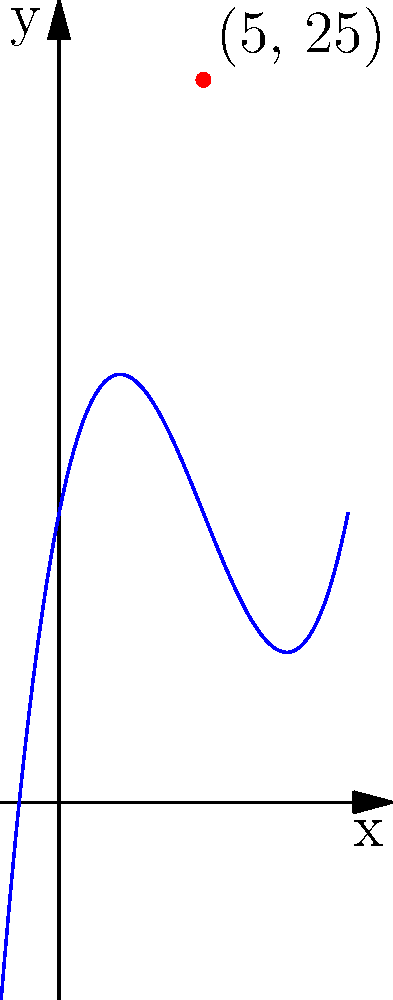As the visual designer for a futuristic sci-fi film, you're tasked with creating a curved set piece for an alien spaceship. The director wants the curve to follow a cubic polynomial function. You've plotted the function $f(x) = 0.1x^3 - 1.5x^2 + 5x + 10$ and determined that the point (5, 25) lies on the curve. What is the slope of the tangent line to the curve at this point? To find the slope of the tangent line at the point (5, 25), we need to follow these steps:

1) The slope of the tangent line at any point is equal to the derivative of the function at that point.

2) First, let's find the derivative of $f(x) = 0.1x^3 - 1.5x^2 + 5x + 10$:
   $f'(x) = 0.3x^2 - 3x + 5$

3) Now, we need to evaluate $f'(x)$ at $x = 5$:
   $f'(5) = 0.3(5)^2 - 3(5) + 5$
   
4) Let's calculate this step by step:
   $f'(5) = 0.3(25) - 15 + 5$
   $f'(5) = 7.5 - 15 + 5$
   $f'(5) = -2.5$

5) Therefore, the slope of the tangent line at the point (5, 25) is -2.5.

This slope indicates how steep the curve is at this specific point, which is crucial for designing the curvature of the futuristic set piece accurately.
Answer: -2.5 